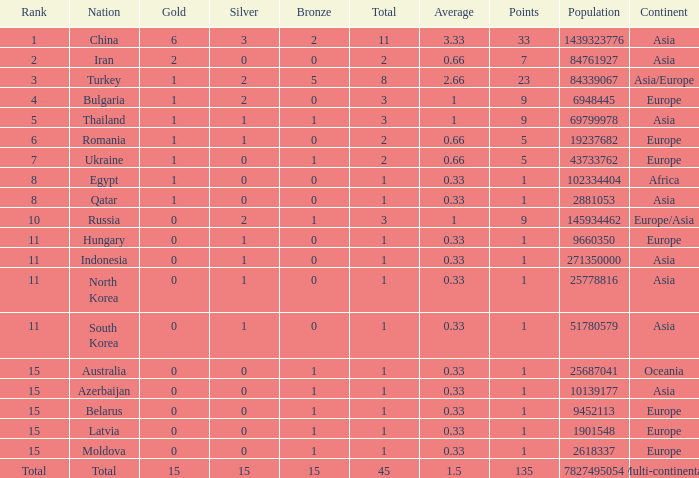Wha is the average number of bronze of hungary, which has less than 1 silver? None. 